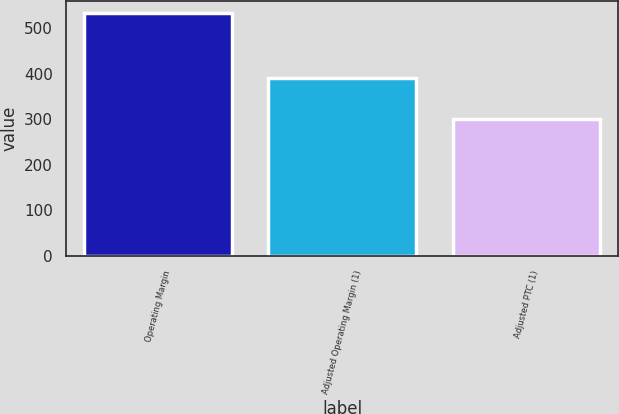Convert chart to OTSL. <chart><loc_0><loc_0><loc_500><loc_500><bar_chart><fcel>Operating Margin<fcel>Adjusted Operating Margin (1)<fcel>Adjusted PTC (1)<nl><fcel>534<fcel>391<fcel>300<nl></chart> 